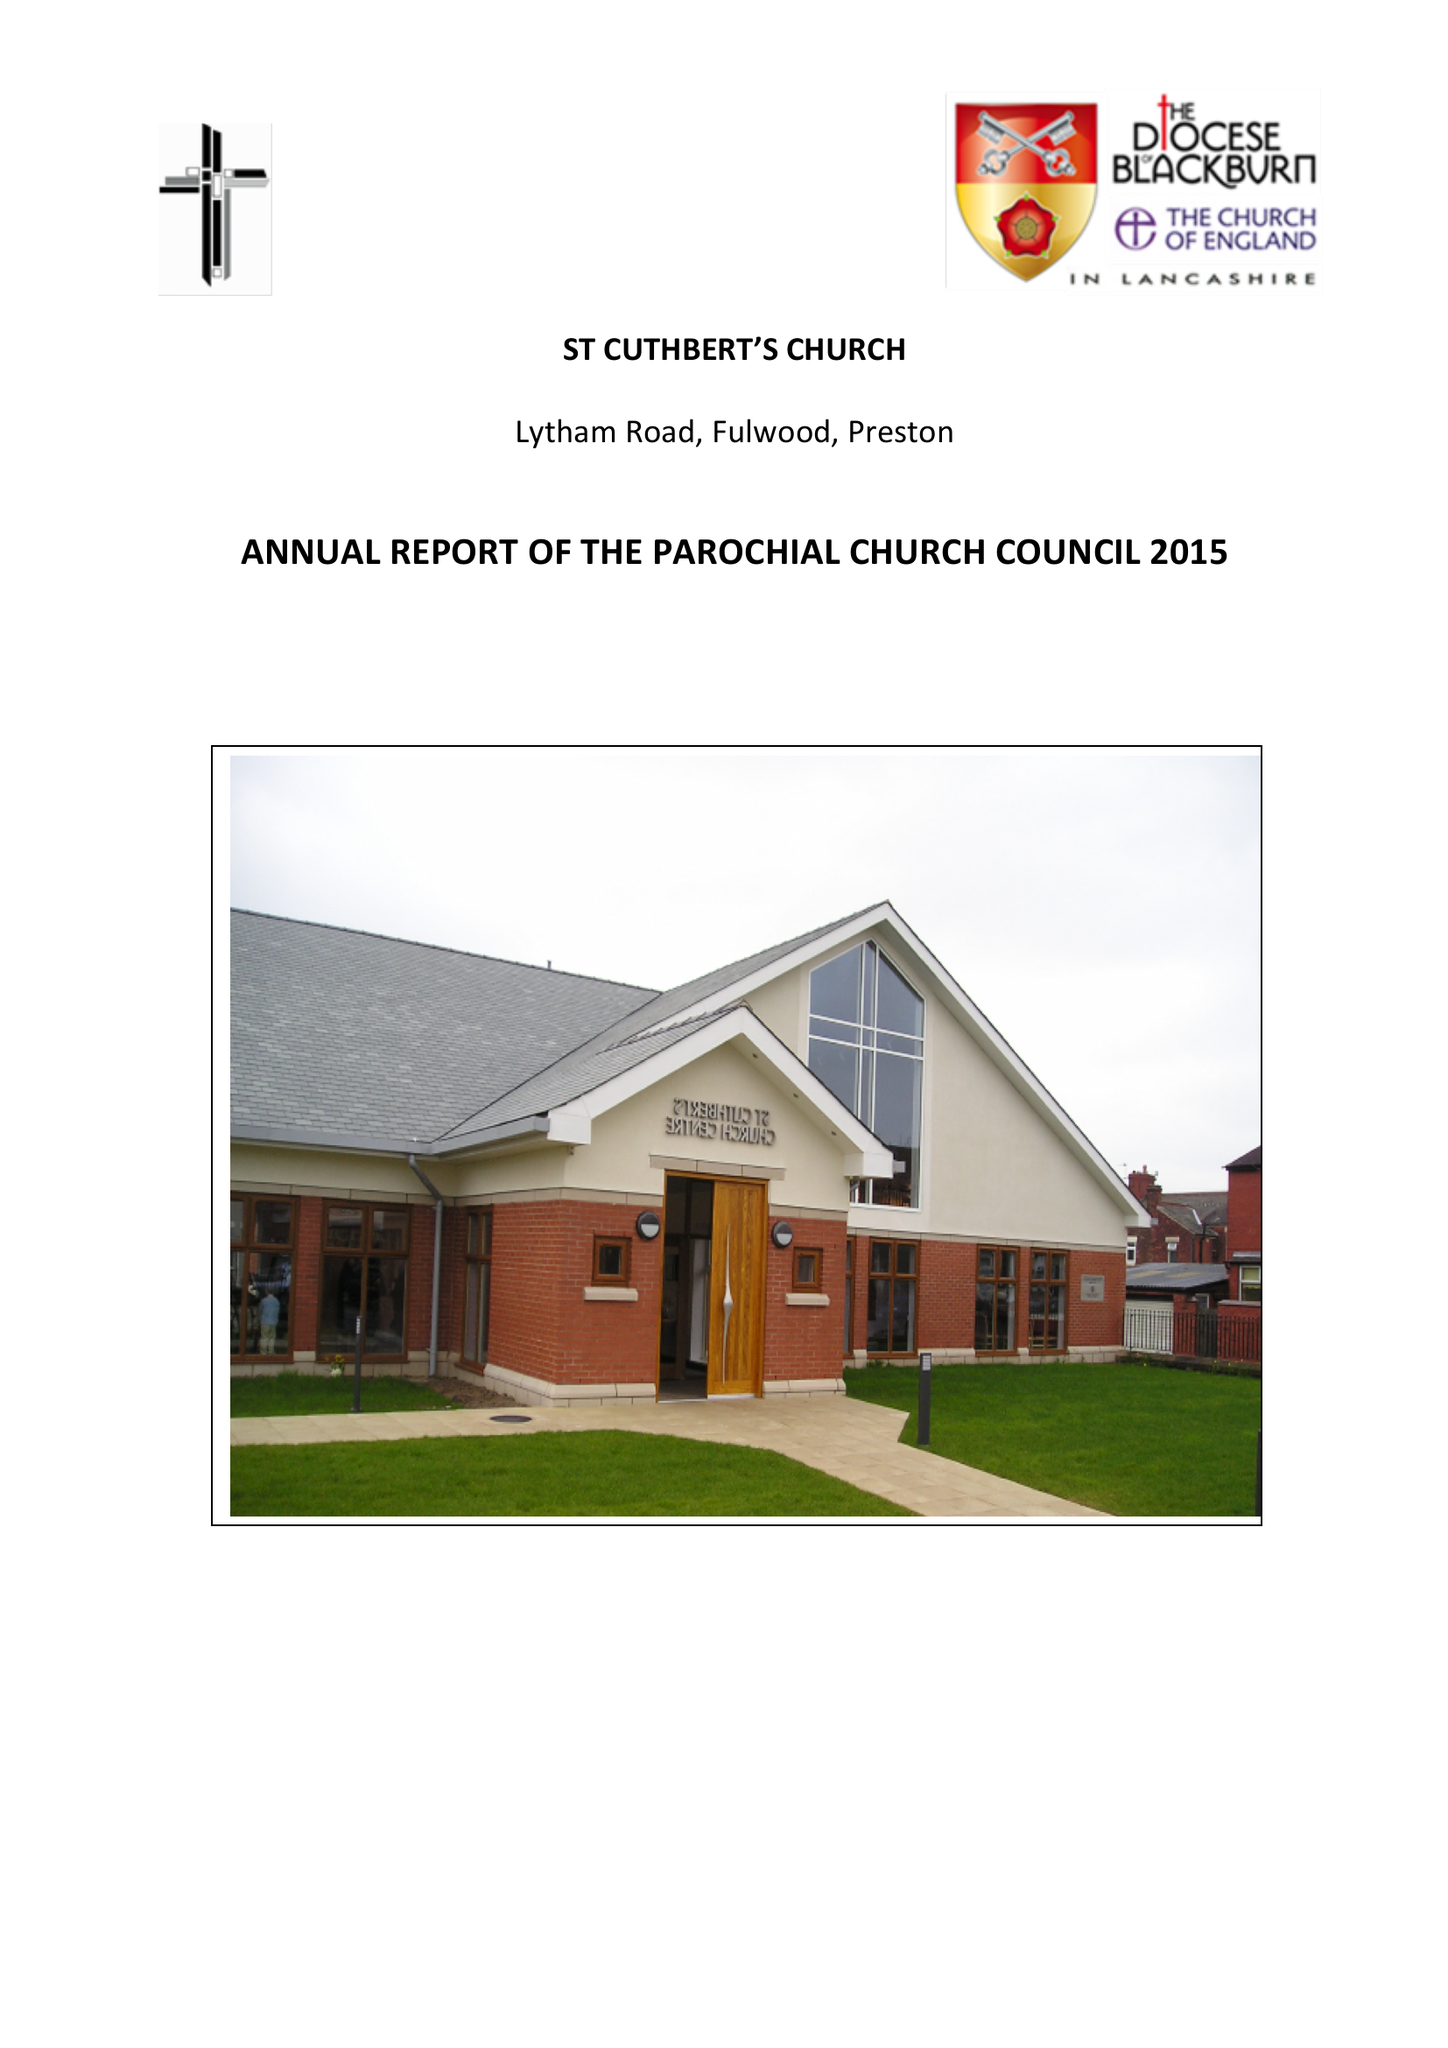What is the value for the address__street_line?
Answer the question using a single word or phrase. LYTHAM ROAD 